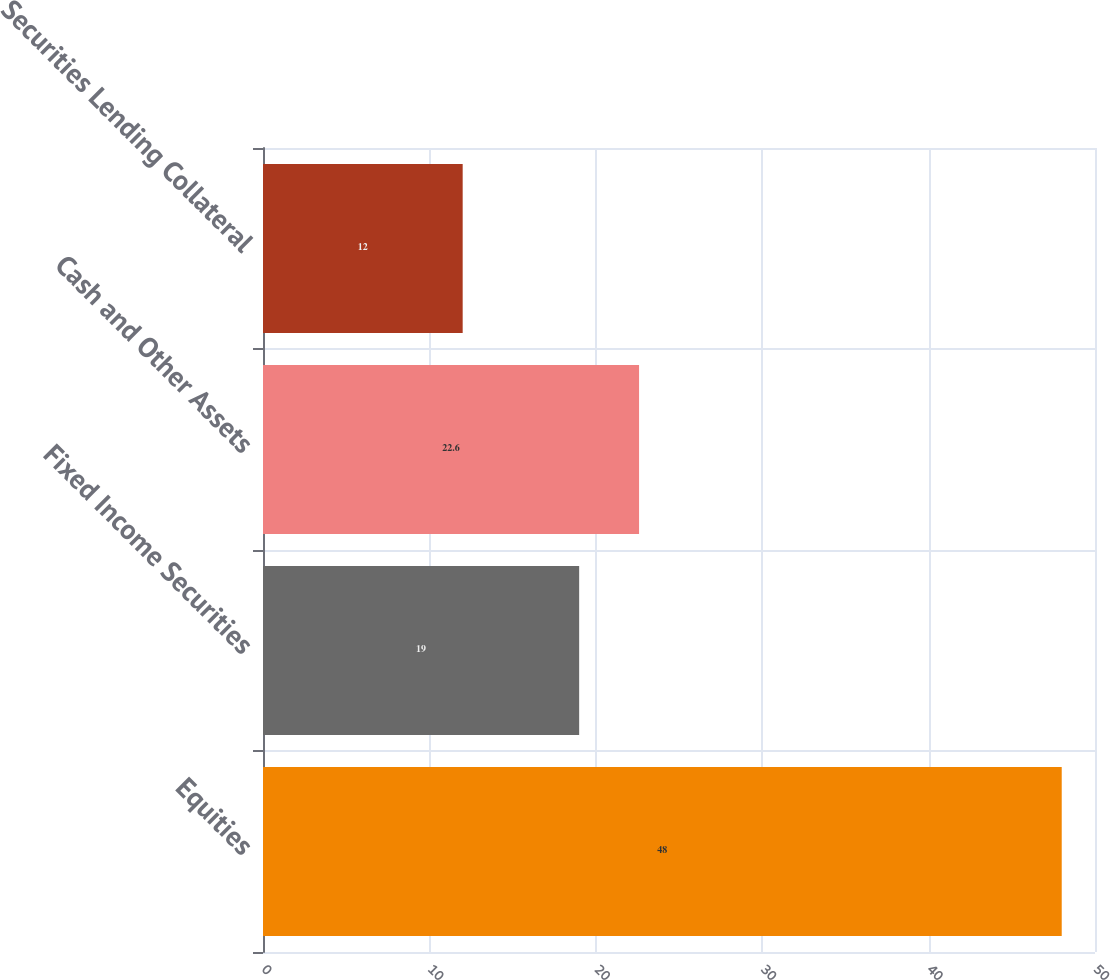Convert chart to OTSL. <chart><loc_0><loc_0><loc_500><loc_500><bar_chart><fcel>Equities<fcel>Fixed Income Securities<fcel>Cash and Other Assets<fcel>Securities Lending Collateral<nl><fcel>48<fcel>19<fcel>22.6<fcel>12<nl></chart> 